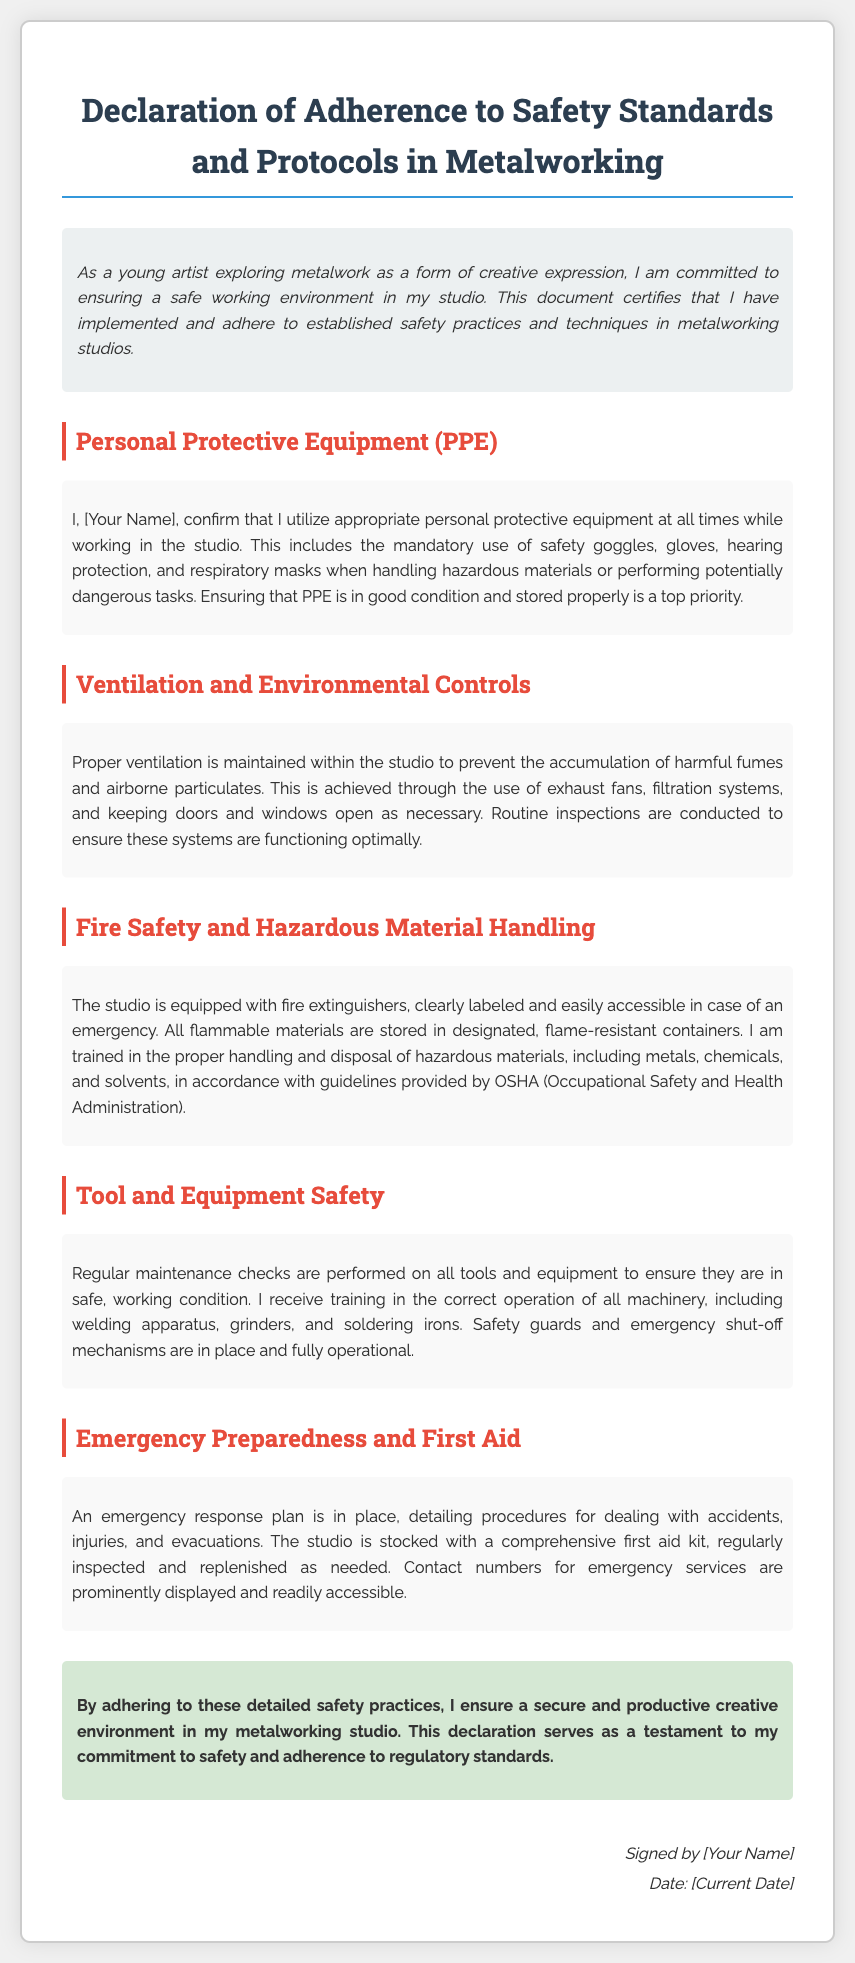What is the title of the document? The title is the main heading in the document, presenting its purpose.
Answer: Declaration of Adherence to Safety Standards and Protocols in Metalworking Who is the individual confirming compliance? The document mentions a placeholder for the person's name who is making the declaration.
Answer: [Your Name] What is included in Personal Protective Equipment (PPE)? PPE includes specific items listed in the section related to safety gear used in the studio.
Answer: safety goggles, gloves, hearing protection, respiratory masks What is the primary purpose of the document? The purpose can be inferred from the introduction discussing commitments to safety standards.
Answer: to ensure a safe working environment Which organization’s guidelines are mentioned in relation to hazardous materials? The document references a regulatory body that provides guidelines for safe practices.
Answer: OSHA What safety measures are highlighted for fire safety? Fire safety measures include specific equipment and storage practices mentioned in the relevant section.
Answer: fire extinguishers, flame-resistant containers How often are maintenance checks performed on tools and equipment? The frequency of checks can be deduced from the details describing the safety practices for tool usage.
Answer: Regularly What type of emergency equipment is guaranteed to be present in the studio? The document states specific emergency supplies included in the preparedness section.
Answer: first aid kit What is required regarding ventilation in the studio? The requirements for maintaining air quality in the workspace are outlined in the ventilation section.
Answer: Proper ventilation is maintained 